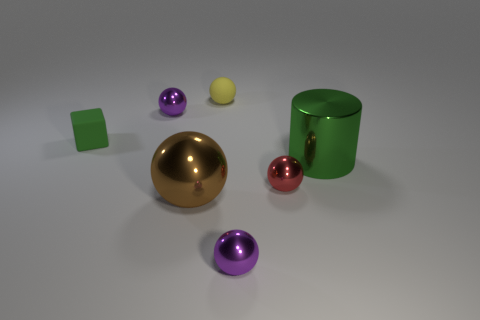Subtract 1 balls. How many balls are left? 4 Subtract all blue balls. Subtract all blue cylinders. How many balls are left? 5 Add 2 green matte cubes. How many objects exist? 9 Subtract all spheres. How many objects are left? 2 Add 7 purple objects. How many purple objects are left? 9 Add 4 tiny cubes. How many tiny cubes exist? 5 Subtract 0 red cubes. How many objects are left? 7 Subtract all small red things. Subtract all green blocks. How many objects are left? 5 